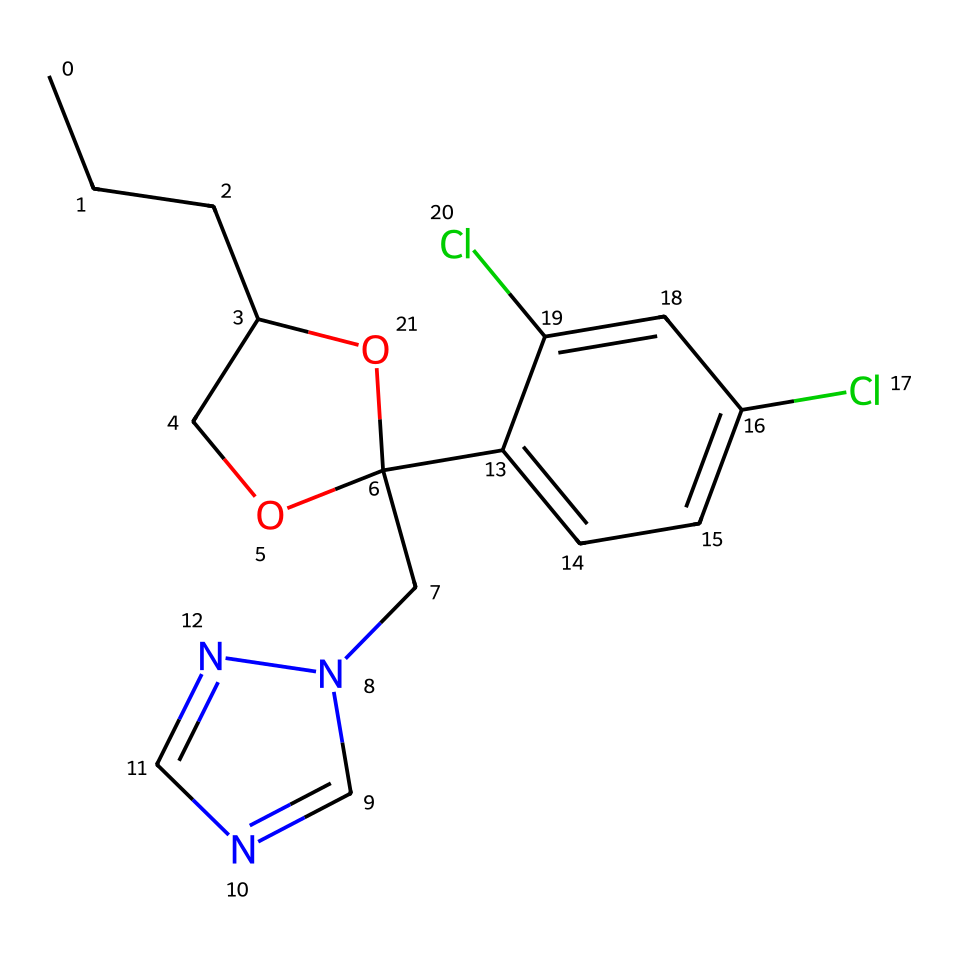What is the total number of carbon atoms in Propiconazole? By examining the provided SMILES representation, we count the number of carbon (C) symbols. There are a total of 12 carbon atoms in the structure.
Answer: 12 How many chlorine atoms are present in the structure? In the SMILES string, we can identify the presence of the Cl symbols. There are 2 chlorine atoms in the chemical structure based on the number of Cl symbols.
Answer: 2 What type of functional group is indicated by the presence of the -O- in the molecule? The presence of the -O- indicates an ether functional group as it is bridging two carbon atoms, showing that it connects different parts of the molecule.
Answer: ether Is this chemical likely to be hydrophilic or hydrophobic? Given the structure contains carbon chains and an ether group but lacks significant polar functional groups, the overall structure suggests it is hydrophobic.
Answer: hydrophobic Which part of the molecule is responsible for its antifungal activity? The presence of the triazole ring (Cn2cncn2) in the molecule is characteristic of antifungal activity as it is involved in inhibiting fungal growth by affecting sterol synthesis.
Answer: triazole ring Does Propiconazole belong to a specific class of fungicides? Yes, based on its chemical structure and its function, Propiconazole belongs to the class of triazole fungicides.
Answer: triazole fungicides What is the molecular formula derived from the structure of Propiconazole? From the analysis of the SMILES representation, we can calculate the molecular formula, which is C12H14Cl2N4O2.
Answer: C12H14Cl2N4O2 